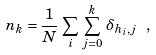<formula> <loc_0><loc_0><loc_500><loc_500>n _ { k } = \frac { 1 } { N } \, \sum _ { i } \, \sum _ { j = 0 } ^ { k } \, \delta _ { h _ { i } , j } \ ,</formula> 